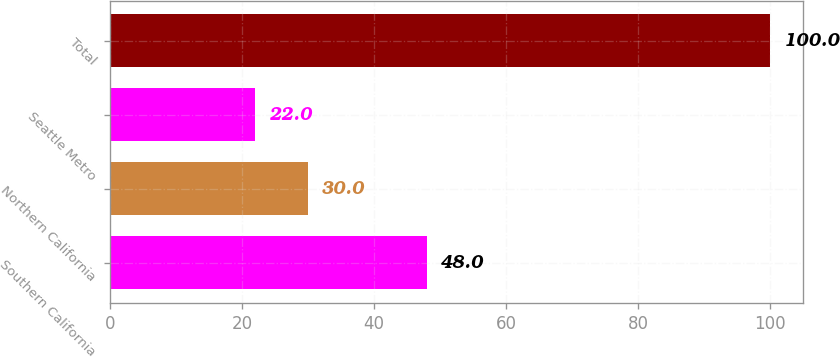<chart> <loc_0><loc_0><loc_500><loc_500><bar_chart><fcel>Southern California<fcel>Northern California<fcel>Seattle Metro<fcel>Total<nl><fcel>48<fcel>30<fcel>22<fcel>100<nl></chart> 